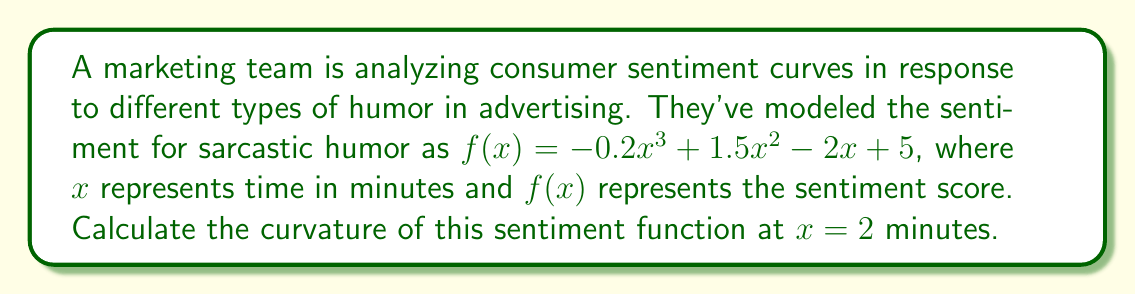Show me your answer to this math problem. To find the curvature of the function at a specific point, we need to use the curvature formula:

$$\kappa = \frac{|f''(x)|}{(1 + [f'(x)]^2)^{3/2}}$$

Let's break this down step-by-step:

1) First, we need to find $f'(x)$ and $f''(x)$:
   
   $f'(x) = -0.6x^2 + 3x - 2$
   $f''(x) = -1.2x + 3$

2) Now, let's evaluate $f'(x)$ and $f''(x)$ at $x = 2$:
   
   $f'(2) = -0.6(2)^2 + 3(2) - 2 = -2.4 + 6 - 2 = 1.6$
   $f''(2) = -1.2(2) + 3 = -2.4 + 3 = 0.6$

3) Next, we can plug these values into the curvature formula:

   $$\kappa = \frac{|0.6|}{(1 + [1.6]^2)^{3/2}}$$

4) Simplify:
   $$\kappa = \frac{0.6}{(1 + 2.56)^{3/2}} = \frac{0.6}{3.56^{3/2}}$$

5) Calculate the final value:
   $$\kappa \approx 0.0891$$

This value represents the curvature of the consumer sentiment function for sarcastic humor at 2 minutes into the advertisement.
Answer: The curvature of the consumer sentiment function for sarcastic humor at $x = 2$ minutes is approximately 0.0891. 